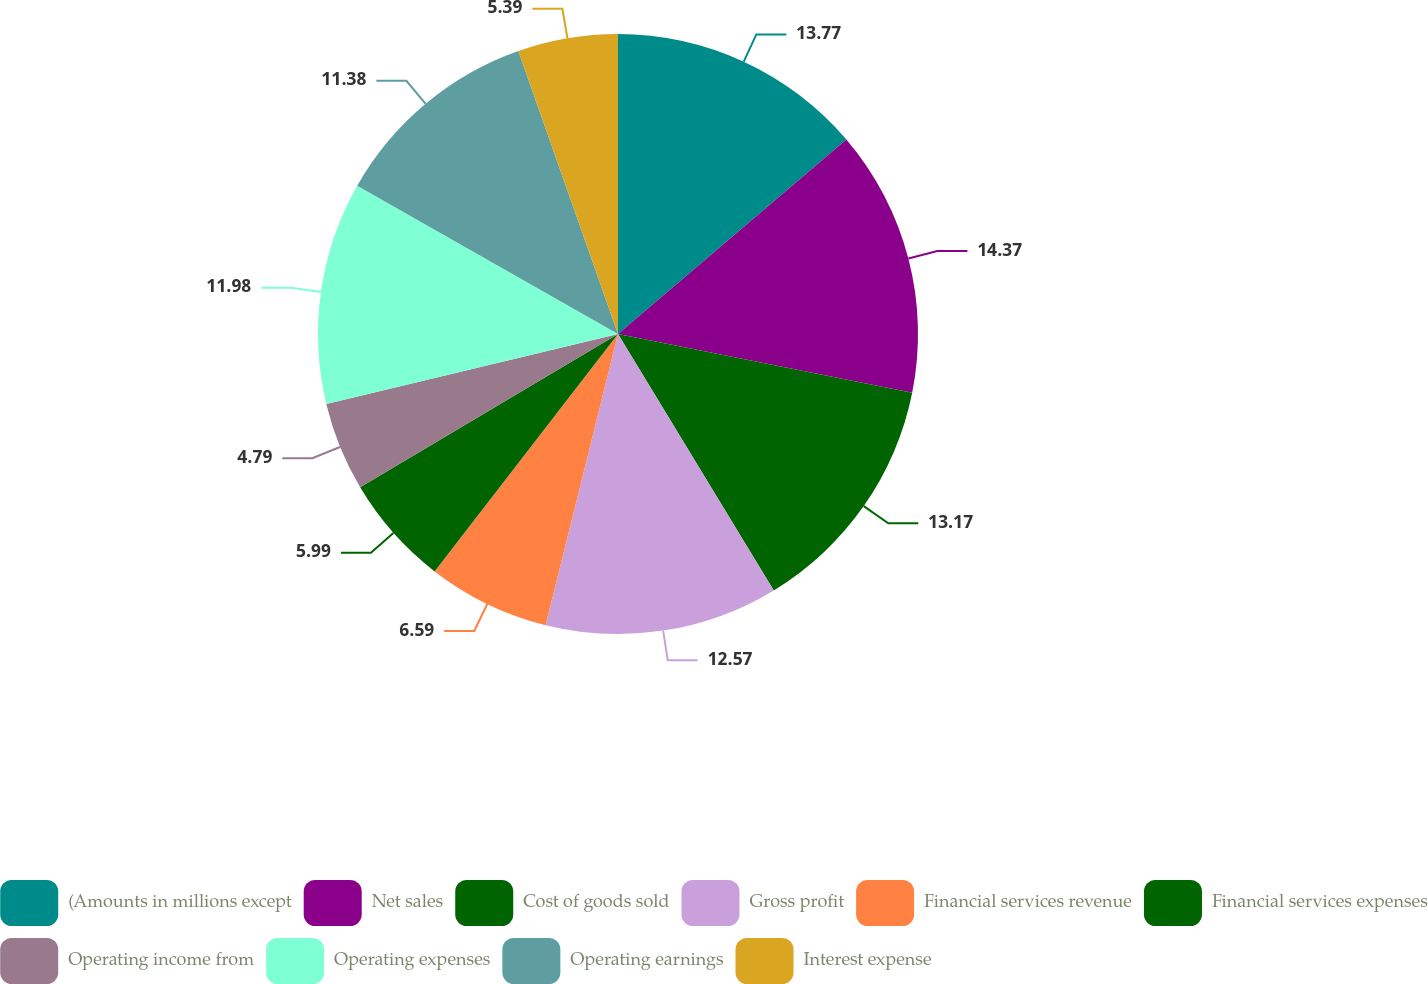Convert chart. <chart><loc_0><loc_0><loc_500><loc_500><pie_chart><fcel>(Amounts in millions except<fcel>Net sales<fcel>Cost of goods sold<fcel>Gross profit<fcel>Financial services revenue<fcel>Financial services expenses<fcel>Operating income from<fcel>Operating expenses<fcel>Operating earnings<fcel>Interest expense<nl><fcel>13.77%<fcel>14.37%<fcel>13.17%<fcel>12.57%<fcel>6.59%<fcel>5.99%<fcel>4.79%<fcel>11.98%<fcel>11.38%<fcel>5.39%<nl></chart> 